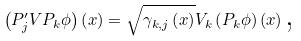Convert formula to latex. <formula><loc_0><loc_0><loc_500><loc_500>\left ( P _ { j } ^ { \prime } V P _ { k } \phi \right ) \left ( x \right ) = \sqrt { \gamma _ { k , j } \left ( x \right ) } V _ { k } \left ( P _ { k } \phi \right ) \left ( x \right ) \text {,}</formula> 